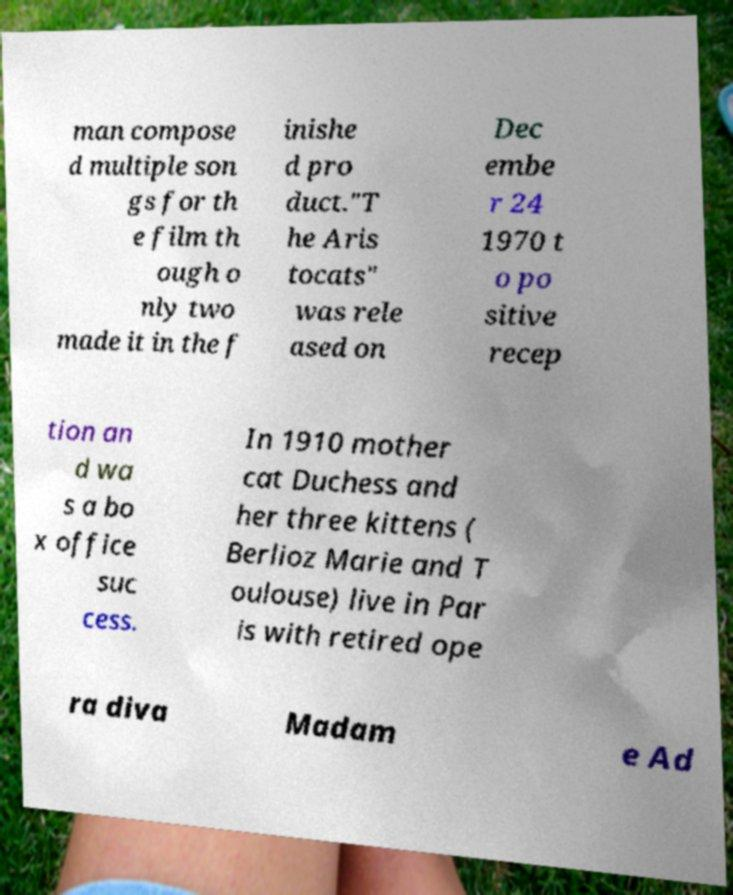Could you extract and type out the text from this image? man compose d multiple son gs for th e film th ough o nly two made it in the f inishe d pro duct."T he Aris tocats" was rele ased on Dec embe r 24 1970 t o po sitive recep tion an d wa s a bo x office suc cess. In 1910 mother cat Duchess and her three kittens ( Berlioz Marie and T oulouse) live in Par is with retired ope ra diva Madam e Ad 